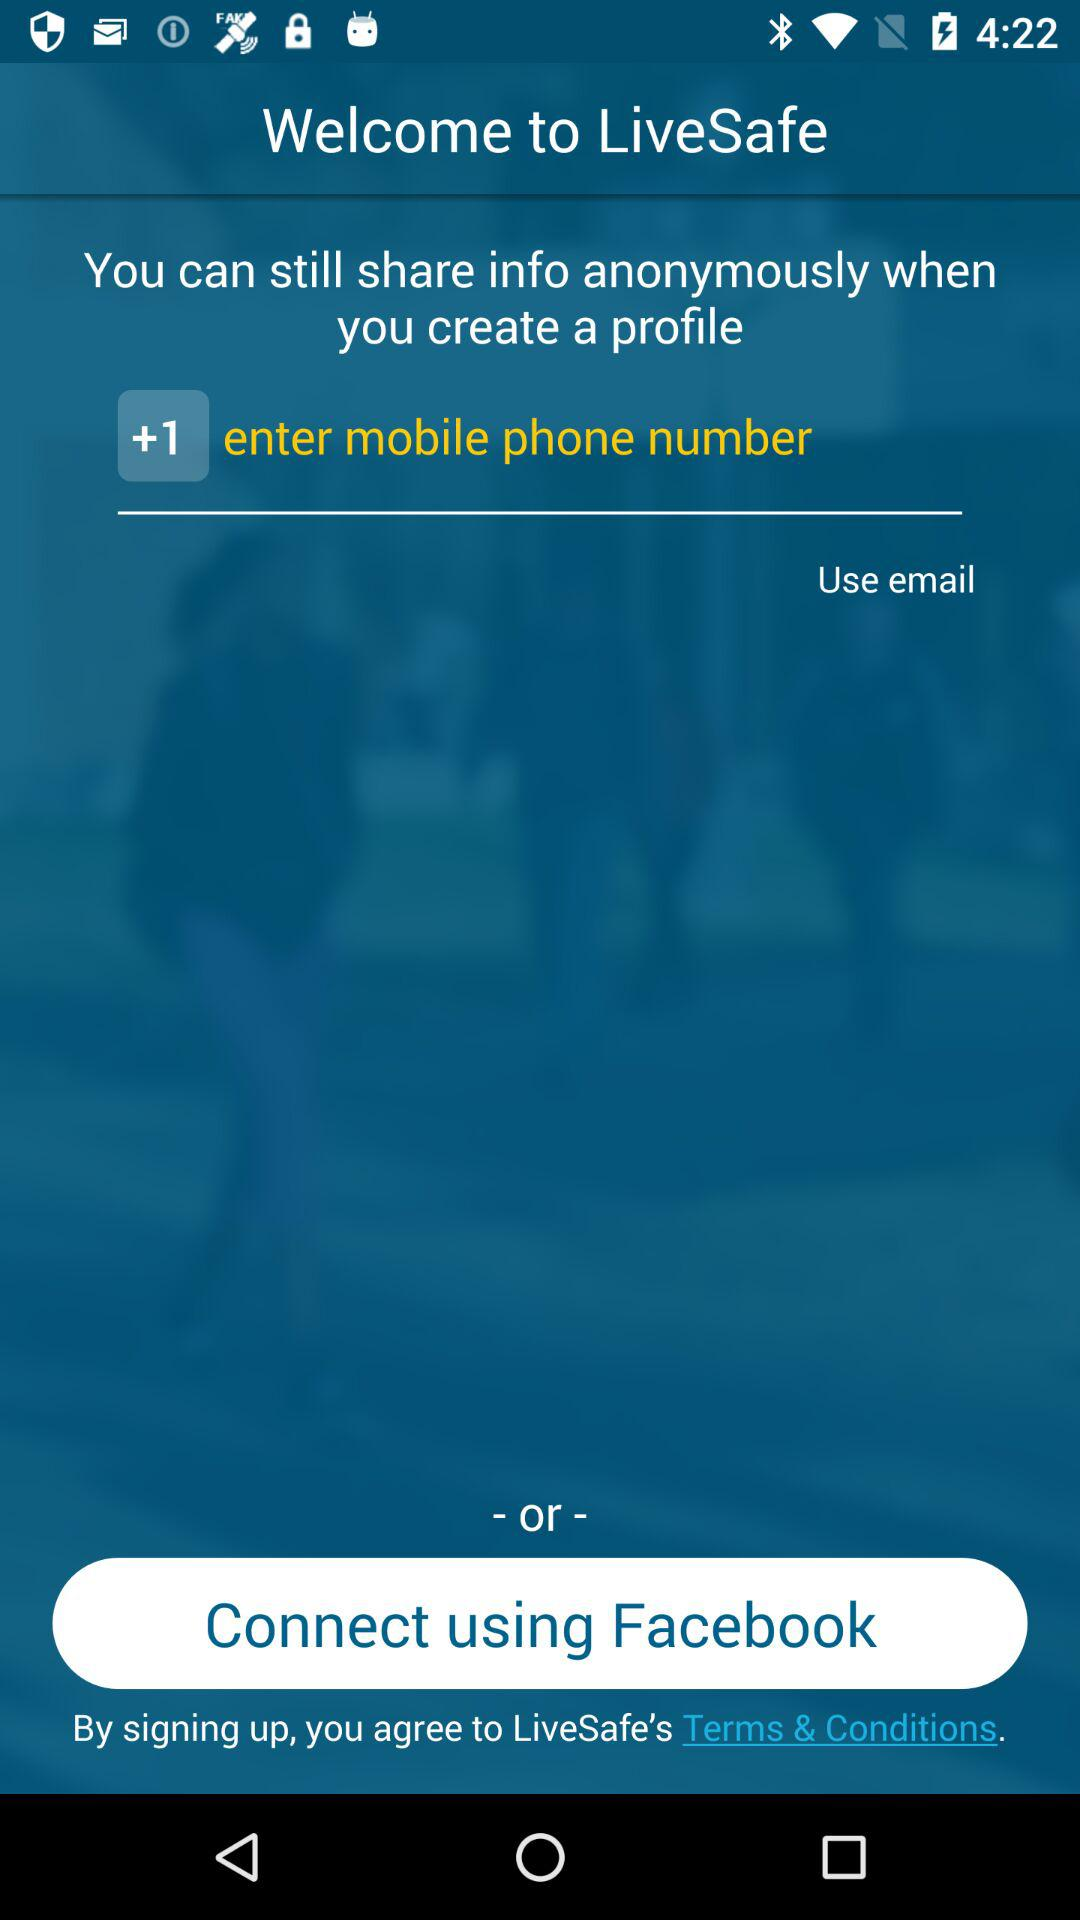What is the selected country code? The selected country code is +1. 